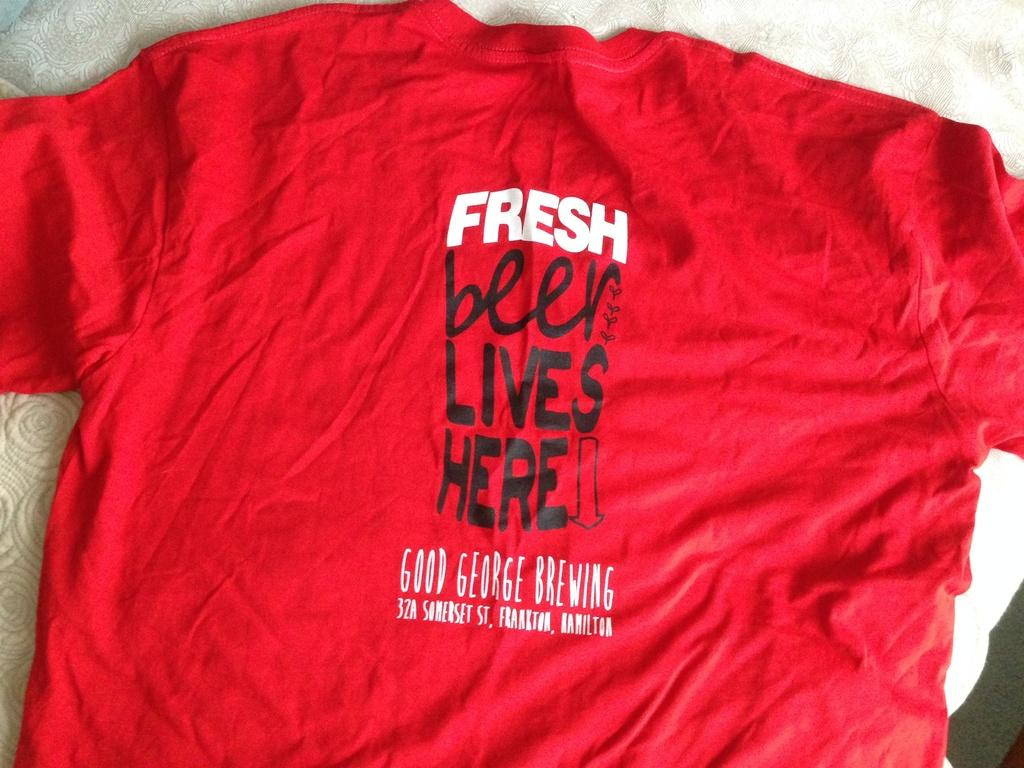<image>
Create a compact narrative representing the image presented. A red T shirt with graphics that say Fresh beer lives here and the address to a brewery. 